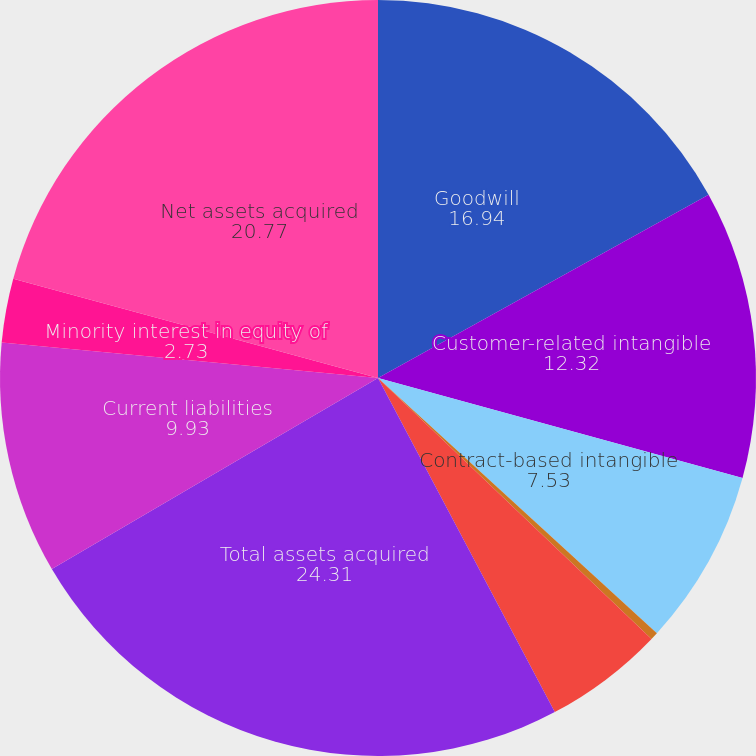<chart> <loc_0><loc_0><loc_500><loc_500><pie_chart><fcel>Goodwill<fcel>Customer-related intangible<fcel>Contract-based intangible<fcel>Property and equipment<fcel>Other current assets<fcel>Total assets acquired<fcel>Current liabilities<fcel>Minority interest in equity of<fcel>Net assets acquired<nl><fcel>16.94%<fcel>12.32%<fcel>7.53%<fcel>0.33%<fcel>5.13%<fcel>24.31%<fcel>9.93%<fcel>2.73%<fcel>20.77%<nl></chart> 